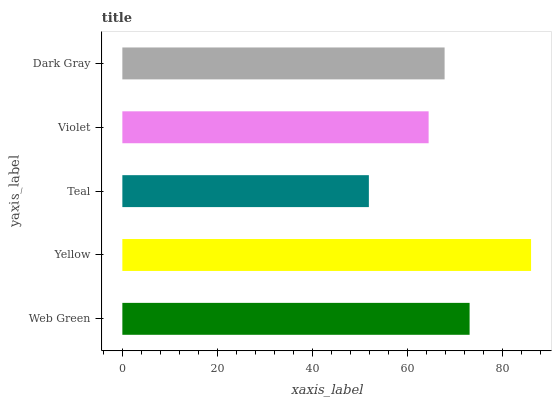Is Teal the minimum?
Answer yes or no. Yes. Is Yellow the maximum?
Answer yes or no. Yes. Is Yellow the minimum?
Answer yes or no. No. Is Teal the maximum?
Answer yes or no. No. Is Yellow greater than Teal?
Answer yes or no. Yes. Is Teal less than Yellow?
Answer yes or no. Yes. Is Teal greater than Yellow?
Answer yes or no. No. Is Yellow less than Teal?
Answer yes or no. No. Is Dark Gray the high median?
Answer yes or no. Yes. Is Dark Gray the low median?
Answer yes or no. Yes. Is Violet the high median?
Answer yes or no. No. Is Violet the low median?
Answer yes or no. No. 